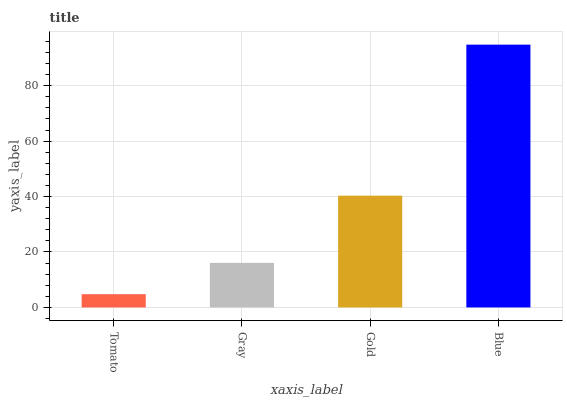Is Tomato the minimum?
Answer yes or no. Yes. Is Blue the maximum?
Answer yes or no. Yes. Is Gray the minimum?
Answer yes or no. No. Is Gray the maximum?
Answer yes or no. No. Is Gray greater than Tomato?
Answer yes or no. Yes. Is Tomato less than Gray?
Answer yes or no. Yes. Is Tomato greater than Gray?
Answer yes or no. No. Is Gray less than Tomato?
Answer yes or no. No. Is Gold the high median?
Answer yes or no. Yes. Is Gray the low median?
Answer yes or no. Yes. Is Gray the high median?
Answer yes or no. No. Is Tomato the low median?
Answer yes or no. No. 